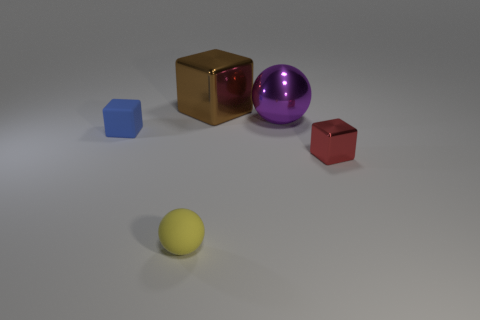Is there any other thing that has the same size as the yellow matte ball?
Keep it short and to the point. Yes. There is a cube on the left side of the big metal cube; how big is it?
Provide a short and direct response. Small. There is a yellow thing that is the same size as the blue matte block; what material is it?
Ensure brevity in your answer.  Rubber. Is the number of small gray rubber spheres greater than the number of large metallic cubes?
Your answer should be compact. No. There is a ball on the left side of the brown thing behind the big purple object; how big is it?
Your answer should be compact. Small. There is a shiny thing that is the same size as the shiny sphere; what shape is it?
Ensure brevity in your answer.  Cube. The thing that is left of the rubber sphere in front of the tiny block on the right side of the big cube is what shape?
Give a very brief answer. Cube. There is a large metal thing in front of the brown metal thing; is it the same color as the small cube that is to the right of the yellow sphere?
Provide a succinct answer. No. What number of tiny blue matte things are there?
Give a very brief answer. 1. Are there any small blue rubber objects behind the blue object?
Offer a terse response. No. 